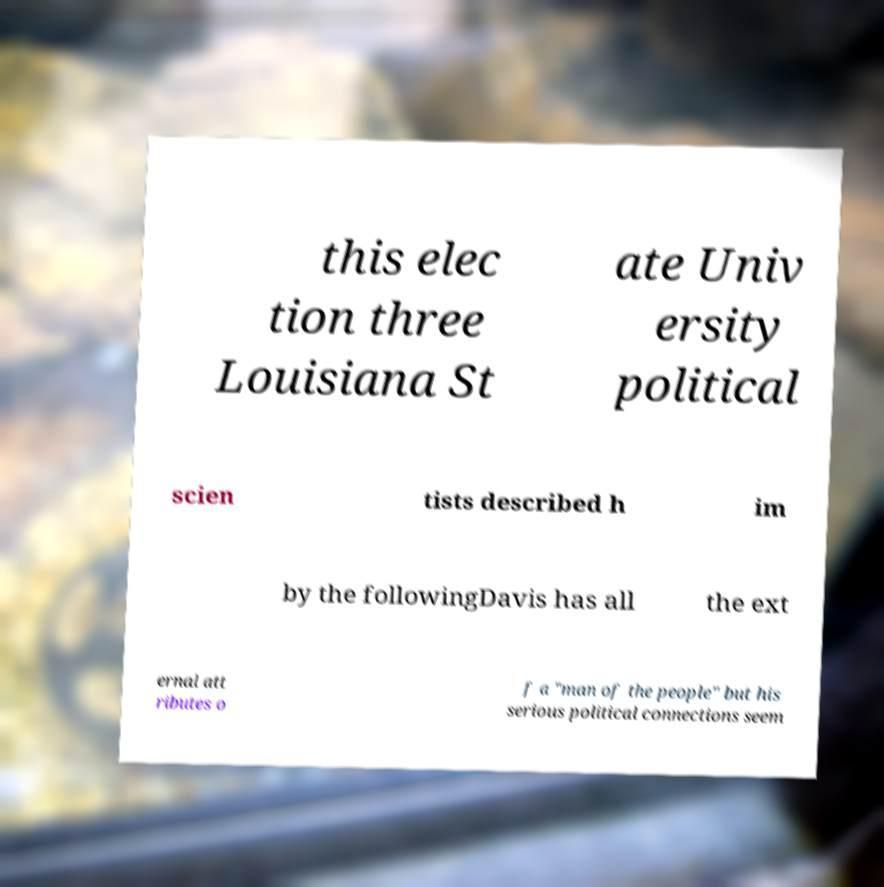What messages or text are displayed in this image? I need them in a readable, typed format. this elec tion three Louisiana St ate Univ ersity political scien tists described h im by the followingDavis has all the ext ernal att ributes o f a "man of the people" but his serious political connections seem 